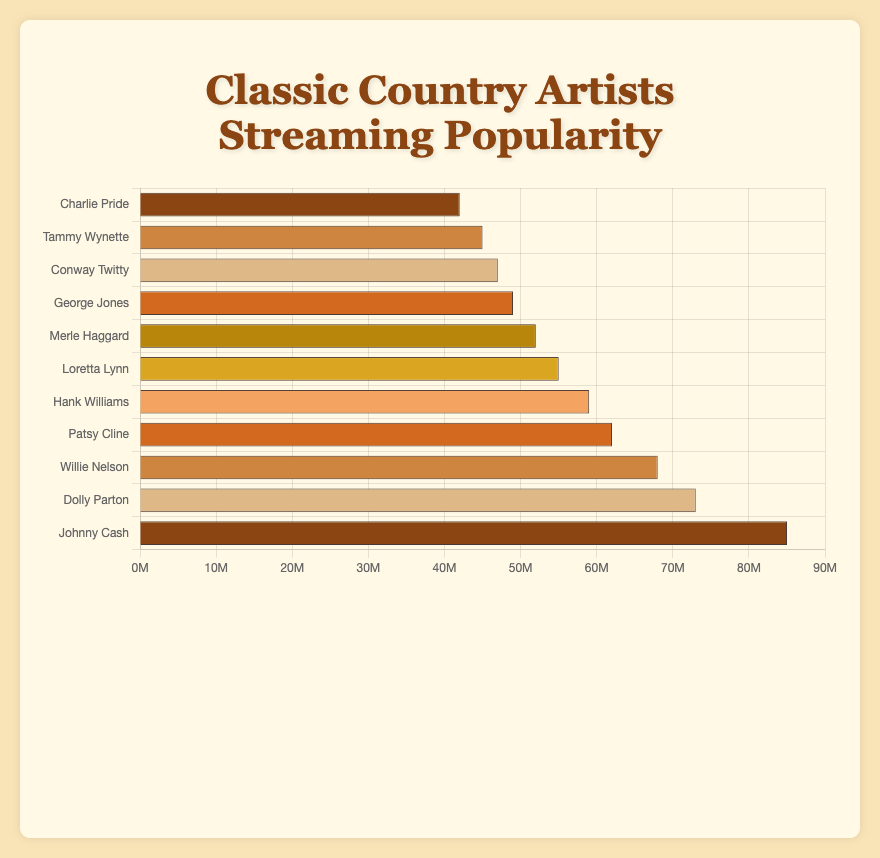What's the total streaming count for all artists combined? Sum the streaming counts of all the artists: 85000000 + 73000000 + 68000000 + 62000000 + 59000000 + 55000000 + 52000000 + 49000000 + 47000000 + 45000000 + 42000000 = 737000000
Answer: 737,000,000 Who is the least popular artist based on streaming counts? Find the artist with the lowest streaming count in the data.
Answer: Charlie Pride How much more streaming counts does Johnny Cash have than Tammy Wynette? Subtract Tammy Wynette's streaming counts from Johnny Cash's streaming counts: 85000000 - 45000000 = 40000000
Answer: 40,000,000 Which two artists have streaming counts that are closest in value? Compare the streaming counts of all artists and identify the two with the smallest difference: 47000000 (Conway Twitty) and 49000000 (George Jones). The difference is
Answer: 2,000,000 What is the average streaming count of the top 3 artists? Sum the streaming counts of the top 3 artists: 85000000 + 73000000 + 68000000 = 226000000, then divide by 3 to find the average: 226000000 / 3 ≈ 75333333
Answer: 75,333,333 Which artist has the second highest streaming counts? Identify the artist with the second highest number of streams after Johnny Cash.
Answer: Dolly Parton How many artists have streaming counts greater than 60 million? Count the number of artists whose streaming counts are greater than 60000000: Johnny Cash, Dolly Parton, Willie Nelson, and Patsy Cline.
Answer: 4 What is the difference in streaming counts between Loretta Lynn and Merle Haggard? Subtract Merle Haggard's streaming counts from Loretta Lynn's streaming counts: 55000000 - 52000000 = 3000000
Answer: 3,000,000 How does the color of Johnny Cash's bar compare to Patsy Cline's bar? Identify the colors associated with Johnny Cash and Patsy Cline's bars. Johnny Cash's bar is the first bar (brown) and Patsy Cline's bar is the fourth bar from the top (brown). Both are brown.
Answer: Both are brown What's the streaming count range amongst the artists? Subtract the smallest streaming count from the largest streaming count: 85000000 (Johnny Cash) - 42000000 (Charlie Pride) = 43000000
Answer: 43,000,000 